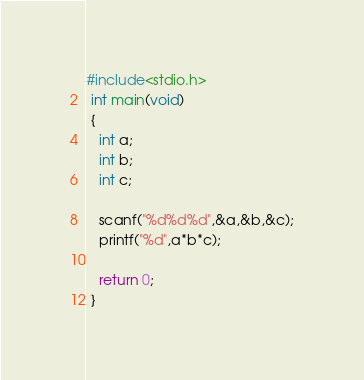Convert code to text. <code><loc_0><loc_0><loc_500><loc_500><_C_>#include<stdio.h>
 int main(void)
 {
   int a;
   int b;
   int c;
   
   scanf("%d%d%d",&a,&b,&c);
   printf("%d",a*b*c);
   
   return 0;
 }
</code> 